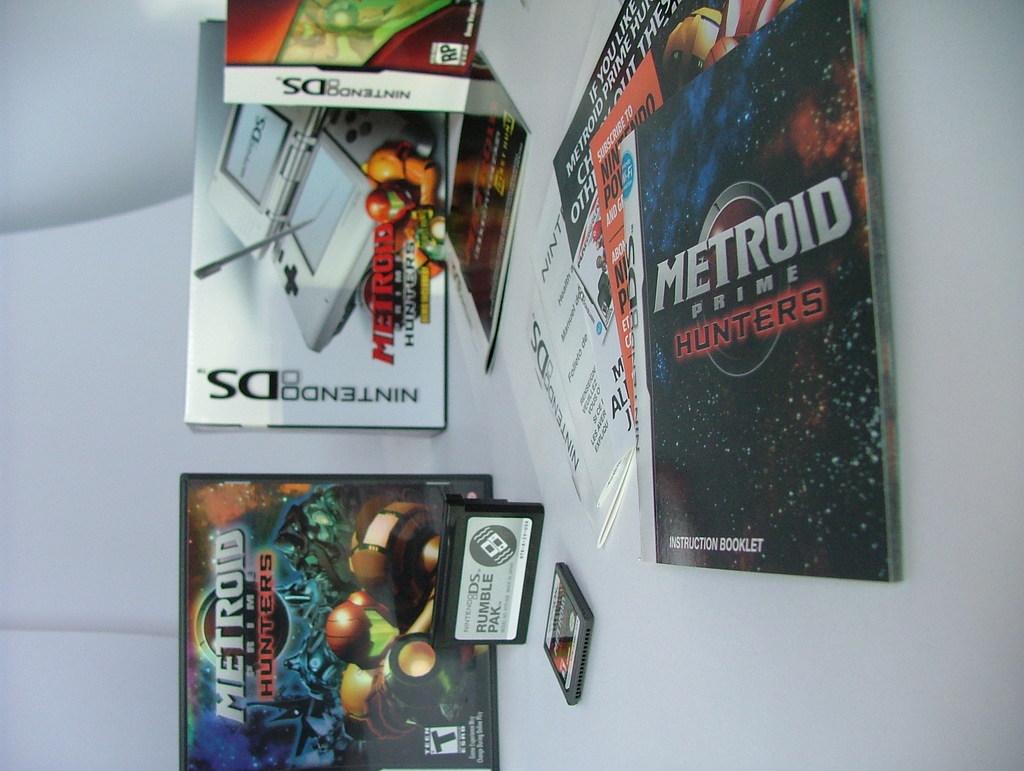What kind of game system are these for?
Provide a succinct answer. Nintendo ds. 